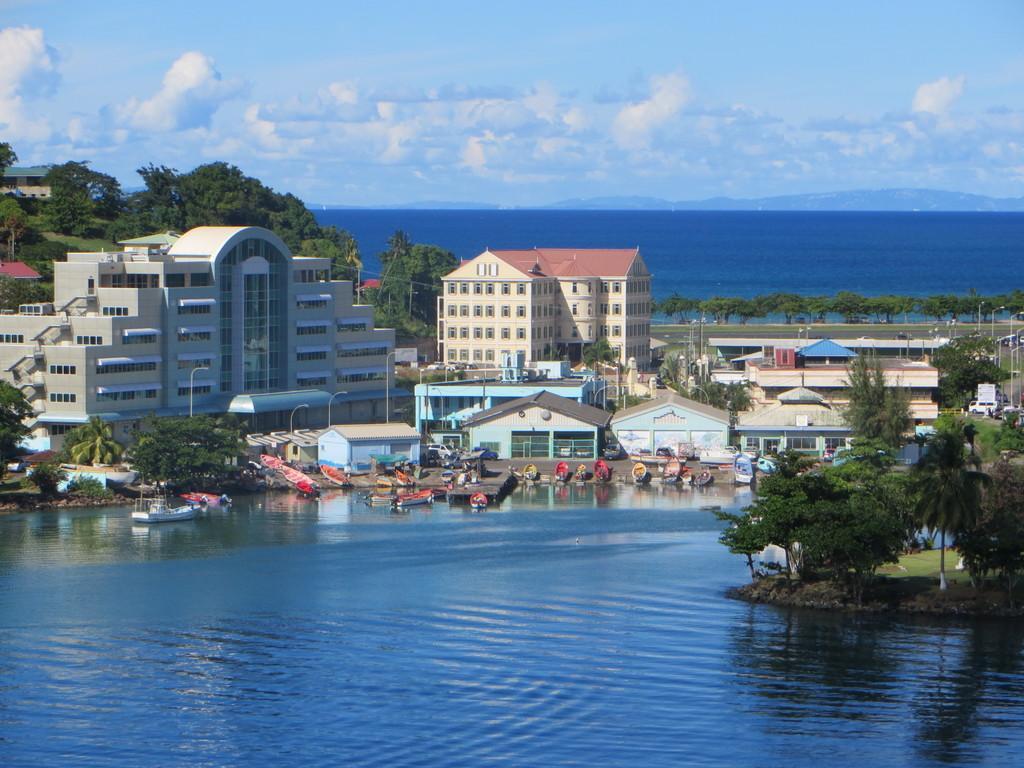Describe this image in one or two sentences. In this image, I can see the buildings, trees, houses, boats, poles, road and water. In the background, there are hills and the sky. 